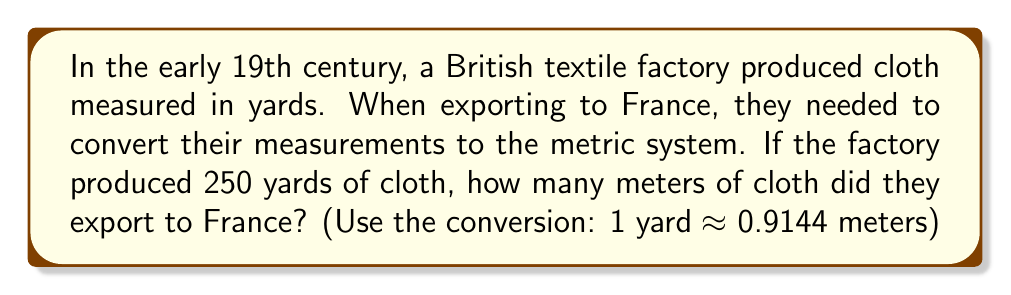Can you solve this math problem? To solve this problem, we need to convert yards to meters using the given conversion factor. Let's break it down step-by-step:

1. We start with the given information:
   - The factory produced 250 yards of cloth
   - 1 yard ≈ 0.9144 meters

2. To convert yards to meters, we multiply the number of yards by the conversion factor:

   $$ \text{Meters} = \text{Yards} \times \text{Conversion Factor} $$

3. Substituting our values:

   $$ \text{Meters} = 250 \times 0.9144 $$

4. Perform the multiplication:

   $$ \text{Meters} = 228.6 $$

Therefore, the British textile factory would export 228.6 meters of cloth to France.
Answer: 228.6 meters 